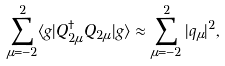<formula> <loc_0><loc_0><loc_500><loc_500>\sum _ { \mu = - 2 } ^ { 2 } \langle g | Q _ { 2 \mu } ^ { \dagger } Q _ { 2 \mu } | g \rangle \approx \sum _ { \mu = - 2 } ^ { 2 } | q _ { \mu } | ^ { 2 } ,</formula> 